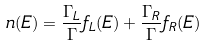Convert formula to latex. <formula><loc_0><loc_0><loc_500><loc_500>n ( E ) = \frac { \Gamma _ { L } } { \Gamma } f _ { L } ( E ) + \frac { \Gamma _ { R } } { \Gamma } f _ { R } ( E )</formula> 